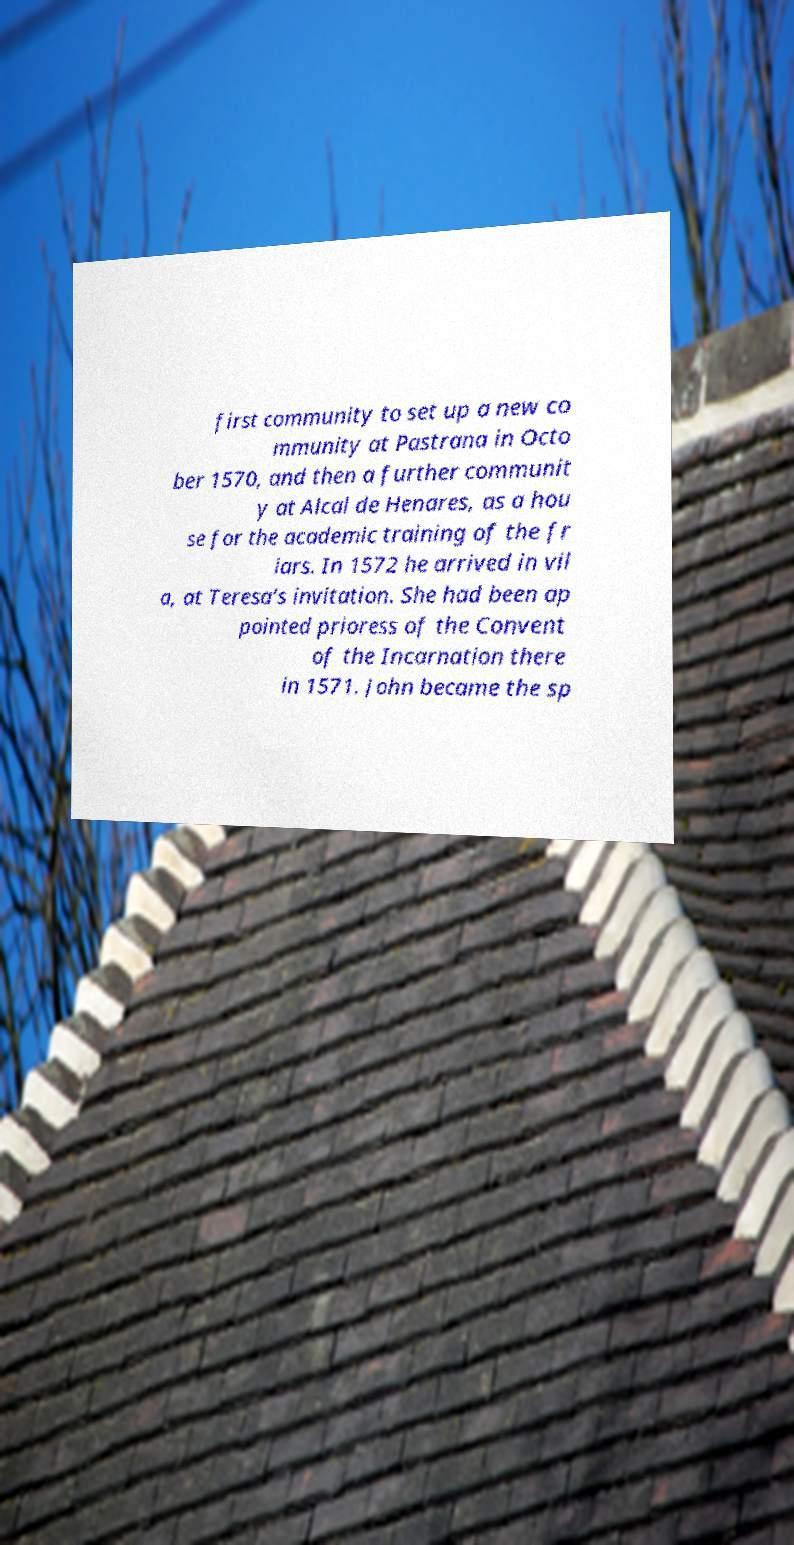Could you assist in decoding the text presented in this image and type it out clearly? first community to set up a new co mmunity at Pastrana in Octo ber 1570, and then a further communit y at Alcal de Henares, as a hou se for the academic training of the fr iars. In 1572 he arrived in vil a, at Teresa's invitation. She had been ap pointed prioress of the Convent of the Incarnation there in 1571. John became the sp 